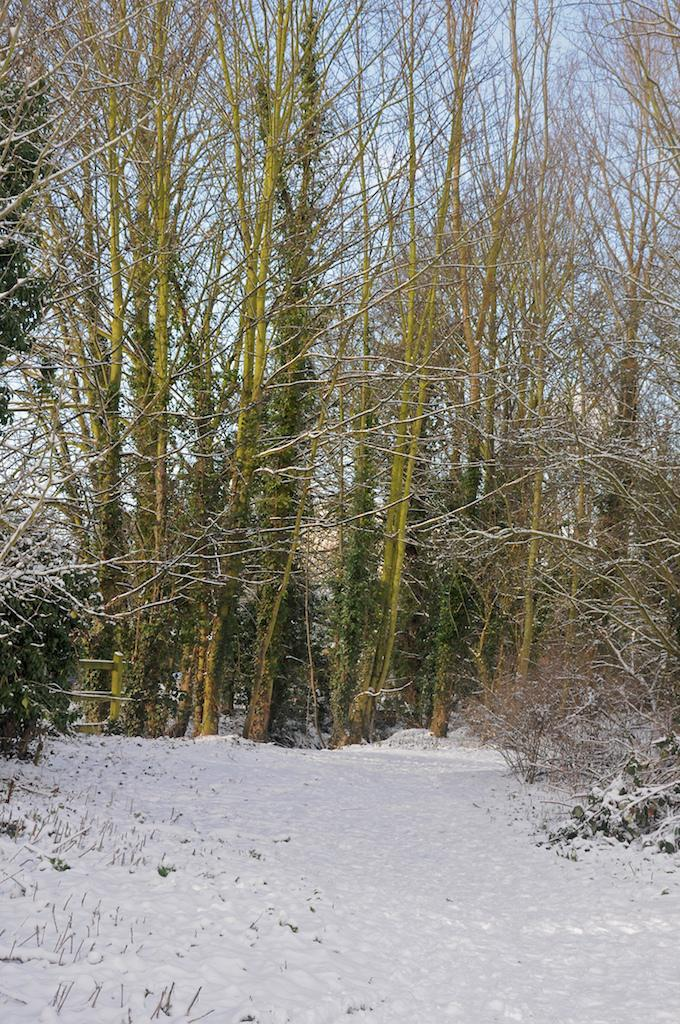What is covering the ground at the bottom of the image? There is snow at the bottom of the image. What is growing in the snow? There are plants in the snow. What can be seen in the distance in the image? There are trees in the background of the image. What is visible above the trees in the image? The sky is visible in the background of the image. What type of camera can be seen in the image? There is no camera present in the image. Can you see a wrench being used to fix the plants in the image? There is no wrench or any repair activity depicted in the image. 